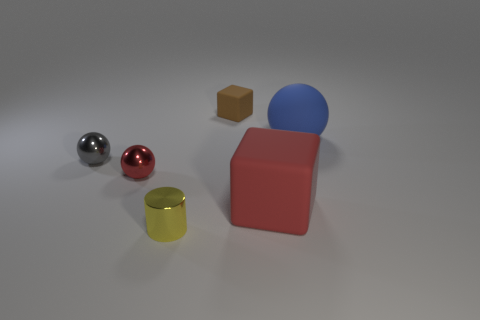What number of other objects are there of the same shape as the tiny yellow thing?
Keep it short and to the point. 0. How many other objects are there of the same material as the brown thing?
Your answer should be compact. 2. What material is the big thing behind the big object in front of the small ball that is on the right side of the gray thing?
Make the answer very short. Rubber. Does the brown object have the same material as the gray ball?
Your response must be concise. No. How many cylinders are either red rubber objects or tiny yellow metallic objects?
Provide a short and direct response. 1. There is a ball that is right of the small brown rubber thing; what is its color?
Ensure brevity in your answer.  Blue. What number of metal things are either tiny balls or large spheres?
Provide a short and direct response. 2. The cube that is in front of the big matte sphere that is behind the gray ball is made of what material?
Make the answer very short. Rubber. There is a ball that is the same color as the big rubber cube; what is its material?
Offer a terse response. Metal. The big rubber ball has what color?
Your answer should be compact. Blue. 